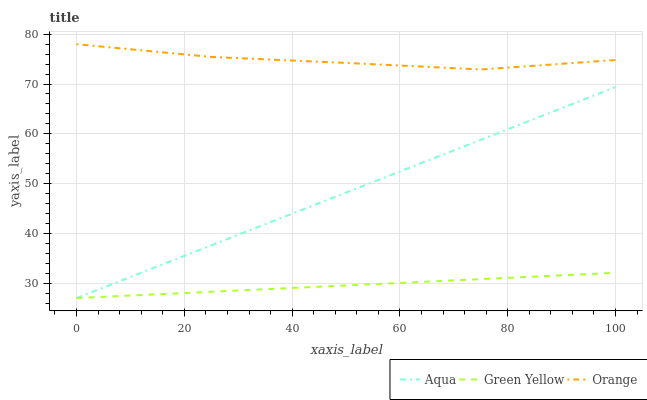Does Green Yellow have the minimum area under the curve?
Answer yes or no. Yes. Does Orange have the maximum area under the curve?
Answer yes or no. Yes. Does Aqua have the minimum area under the curve?
Answer yes or no. No. Does Aqua have the maximum area under the curve?
Answer yes or no. No. Is Green Yellow the smoothest?
Answer yes or no. Yes. Is Orange the roughest?
Answer yes or no. Yes. Is Aqua the smoothest?
Answer yes or no. No. Is Aqua the roughest?
Answer yes or no. No. Does Green Yellow have the lowest value?
Answer yes or no. Yes. Does Orange have the highest value?
Answer yes or no. Yes. Does Aqua have the highest value?
Answer yes or no. No. Is Green Yellow less than Orange?
Answer yes or no. Yes. Is Orange greater than Aqua?
Answer yes or no. Yes. Does Green Yellow intersect Aqua?
Answer yes or no. Yes. Is Green Yellow less than Aqua?
Answer yes or no. No. Is Green Yellow greater than Aqua?
Answer yes or no. No. Does Green Yellow intersect Orange?
Answer yes or no. No. 